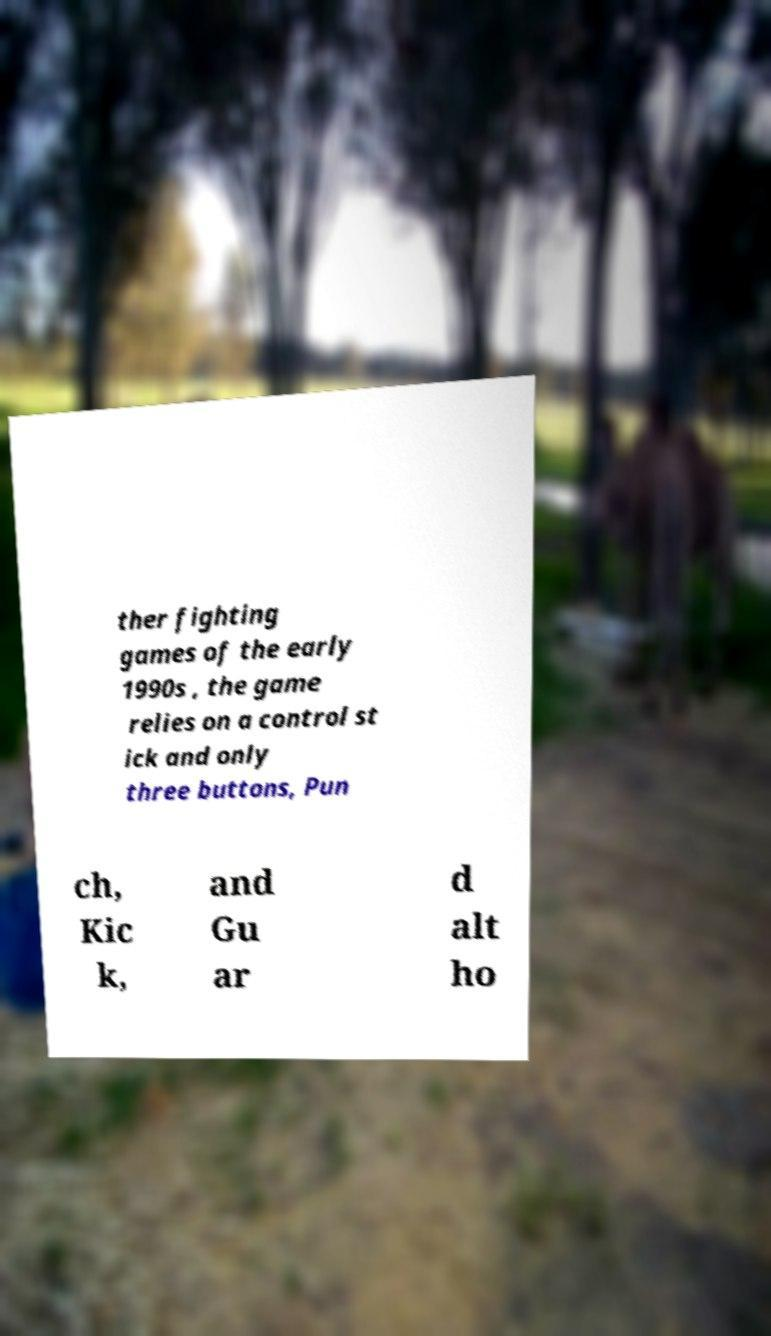For documentation purposes, I need the text within this image transcribed. Could you provide that? ther fighting games of the early 1990s , the game relies on a control st ick and only three buttons, Pun ch, Kic k, and Gu ar d alt ho 